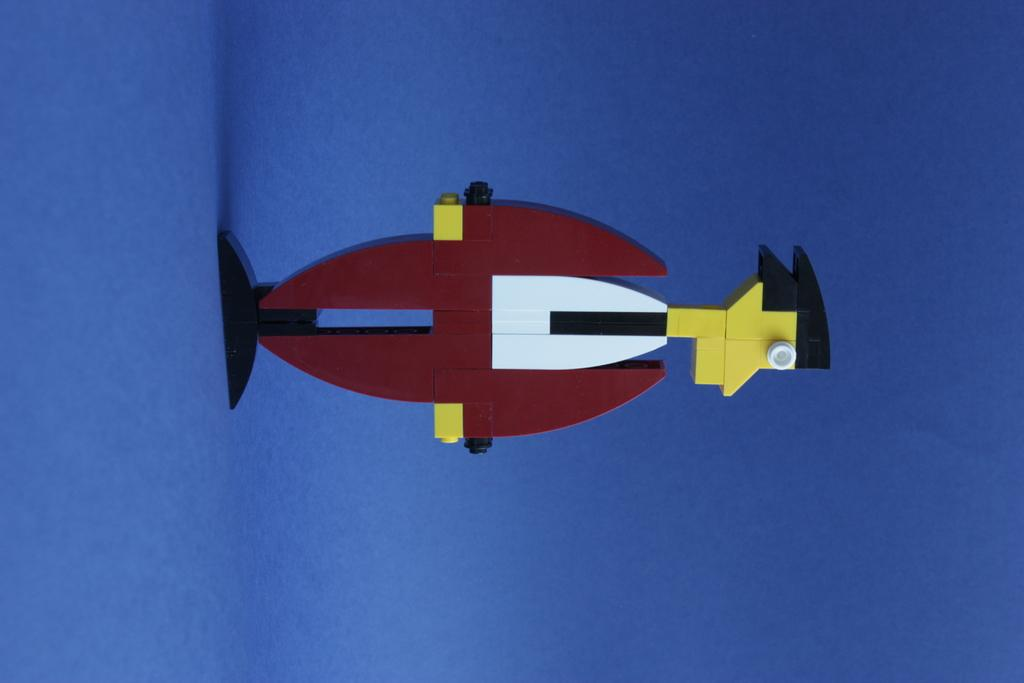What can be seen in the image? There is an object in the image. What colors are present on the object? The object has white, maroon, yellow, and black colors. What is the color of the surface the object is placed on? The object is on a blue surface. Can you tell me how many apples are on the object in the image? There is no apple present on the object in the image. Is the object in the image maintaining balance on the blue surface? The question of balance is not relevant to the image, as it does not show any objects in motion or precarious positions. 